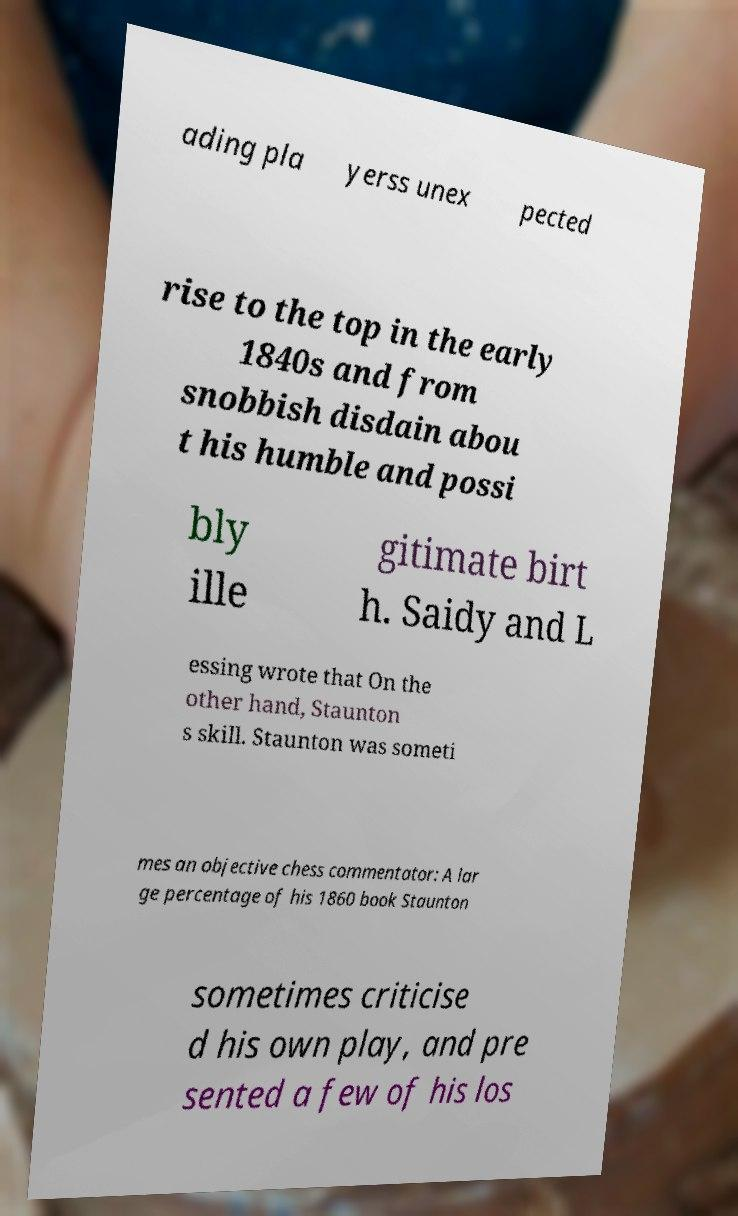Please read and relay the text visible in this image. What does it say? ading pla yerss unex pected rise to the top in the early 1840s and from snobbish disdain abou t his humble and possi bly ille gitimate birt h. Saidy and L essing wrote that On the other hand, Staunton s skill. Staunton was someti mes an objective chess commentator: A lar ge percentage of his 1860 book Staunton sometimes criticise d his own play, and pre sented a few of his los 